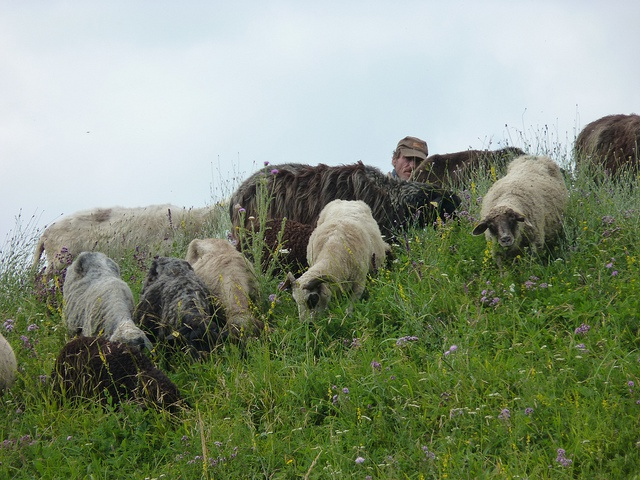Describe the objects in this image and their specific colors. I can see sheep in lightgray, black, gray, and darkgreen tones, sheep in lightgray, darkgray, gray, and darkgreen tones, sheep in lightgray, gray, darkgray, and black tones, sheep in lightgray, black, darkgreen, and gray tones, and sheep in lightgray, black, gray, and darkgreen tones in this image. 